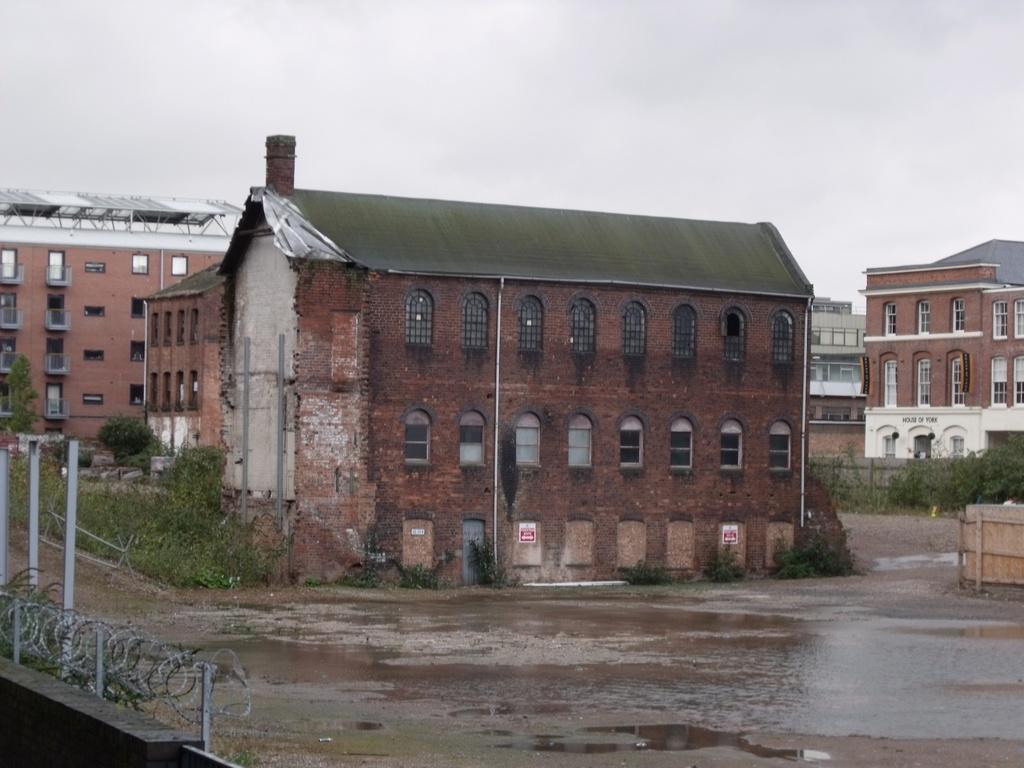In one or two sentences, can you explain what this image depicts? In this image we can see few buildings, grass, plants in front of the building, there is a shed on the top of the building, there is a fence on the wall and there are rods and sky in the background. 